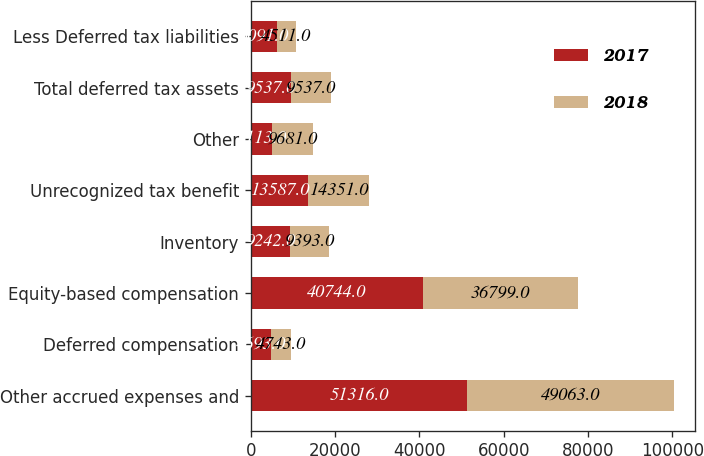<chart> <loc_0><loc_0><loc_500><loc_500><stacked_bar_chart><ecel><fcel>Other accrued expenses and<fcel>Deferred compensation<fcel>Equity-based compensation<fcel>Inventory<fcel>Unrecognized tax benefit<fcel>Other<fcel>Total deferred tax assets<fcel>Less Deferred tax liabilities<nl><fcel>2017<fcel>51316<fcel>4693<fcel>40744<fcel>9242<fcel>13587<fcel>5113<fcel>9537<fcel>6091<nl><fcel>2018<fcel>49063<fcel>4743<fcel>36799<fcel>9393<fcel>14351<fcel>9681<fcel>9537<fcel>4511<nl></chart> 